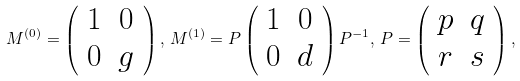Convert formula to latex. <formula><loc_0><loc_0><loc_500><loc_500>M ^ { ( 0 ) } = \left ( \begin{array} { c c } 1 & 0 \\ 0 & g \end{array} \right ) , \, M ^ { ( 1 ) } = P \left ( \begin{array} { c c } 1 & 0 \\ 0 & d \end{array} \right ) P ^ { - 1 } , \, P = \left ( \begin{array} { c c } p & q \\ r & s \end{array} \right ) ,</formula> 